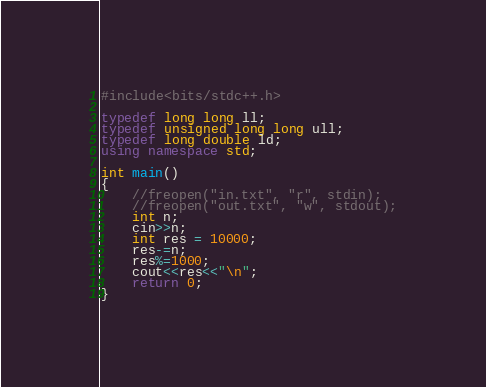Convert code to text. <code><loc_0><loc_0><loc_500><loc_500><_C++_>#include<bits/stdc++.h>

typedef long long ll;
typedef unsigned long long ull;
typedef long double ld;
using namespace std;

int main()
{
    //freopen("in.txt", "r", stdin);
    //freopen("out.txt", "w", stdout);
    int n;
    cin>>n;
    int res = 10000;
    res-=n;
    res%=1000;
    cout<<res<<"\n";
    return 0;
}
</code> 